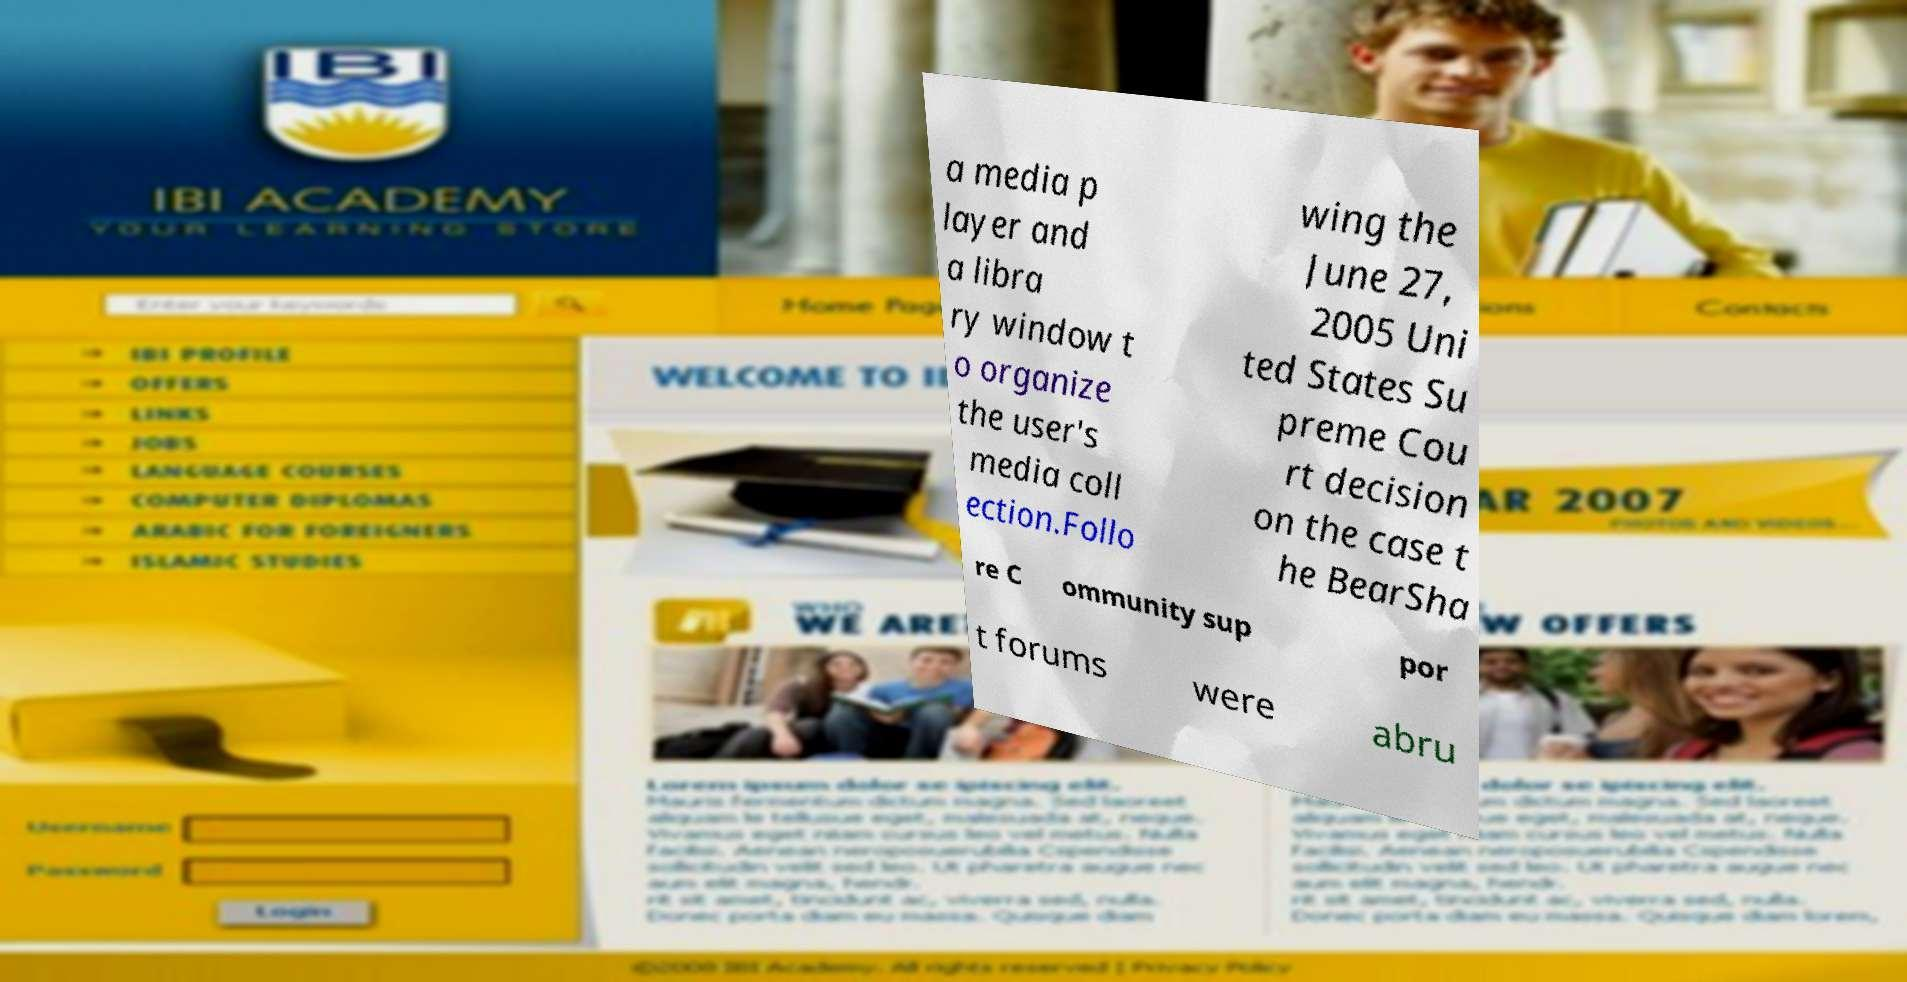There's text embedded in this image that I need extracted. Can you transcribe it verbatim? a media p layer and a libra ry window t o organize the user's media coll ection.Follo wing the June 27, 2005 Uni ted States Su preme Cou rt decision on the case t he BearSha re C ommunity sup por t forums were abru 